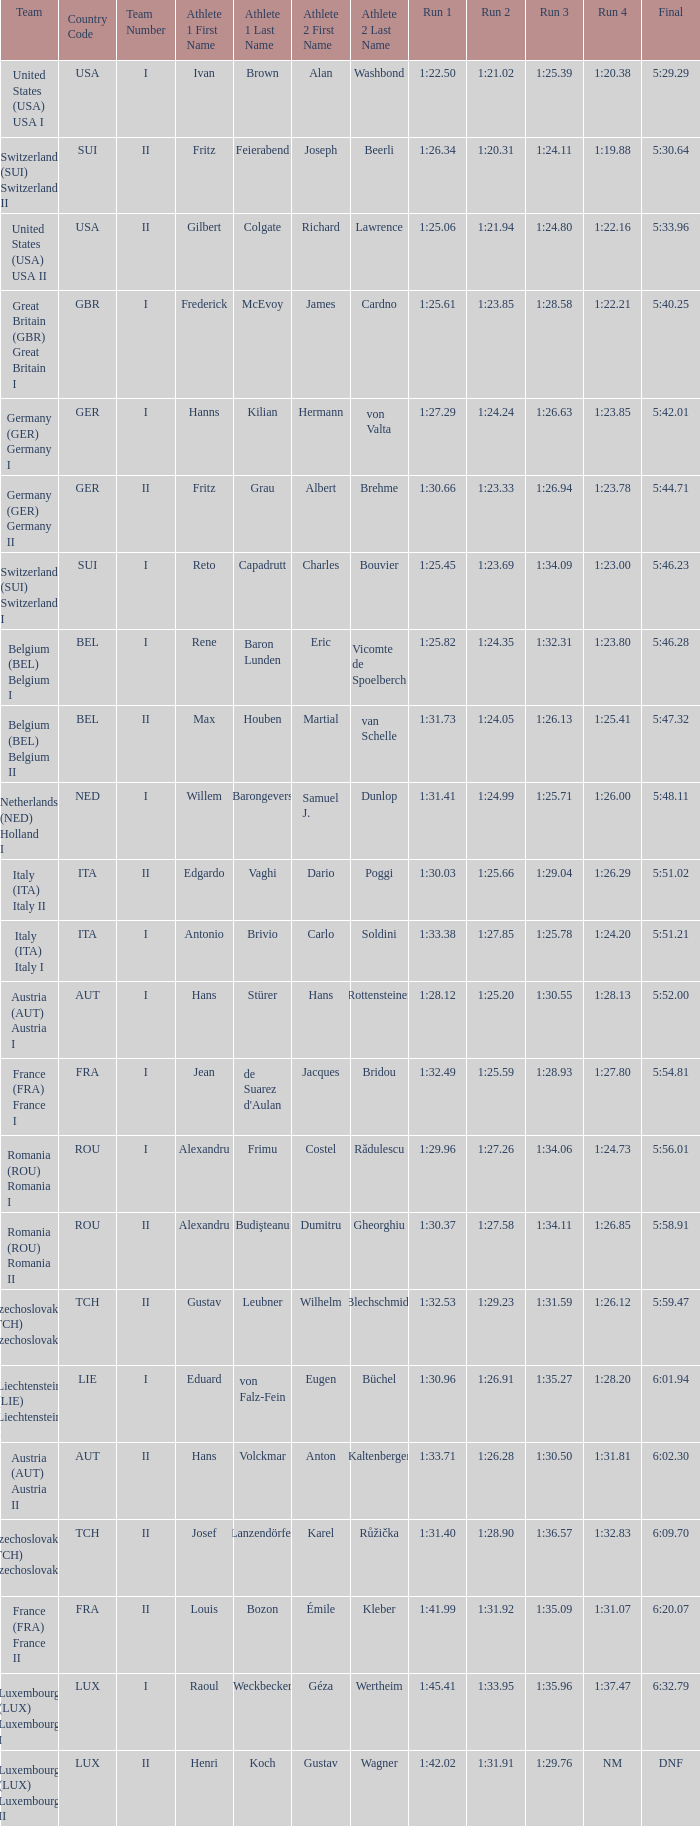In which final is there a team from liechtenstein (lie) liechtenstein i? 6:01.94. 